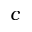Convert formula to latex. <formula><loc_0><loc_0><loc_500><loc_500>c</formula> 